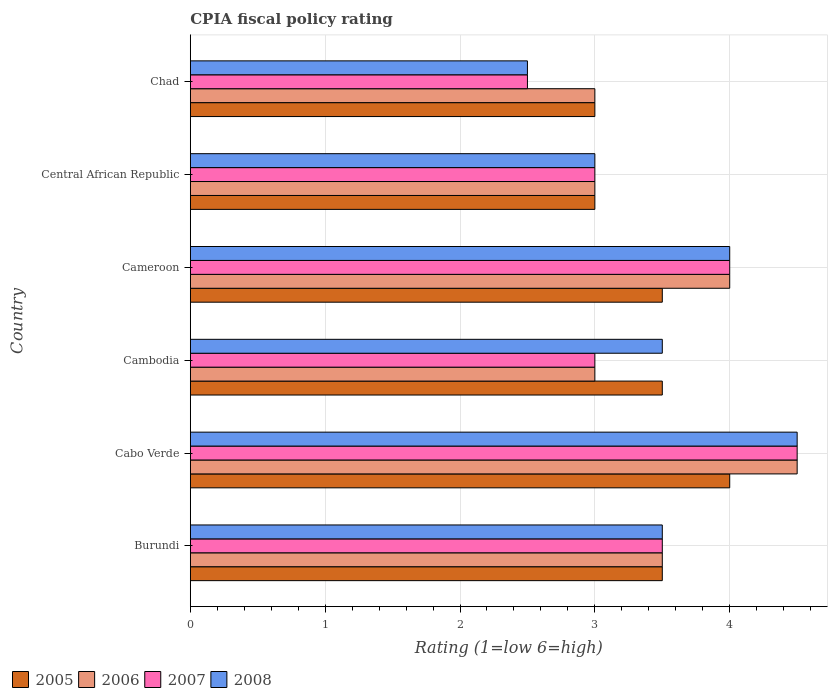How many groups of bars are there?
Provide a succinct answer. 6. Are the number of bars per tick equal to the number of legend labels?
Your answer should be compact. Yes. Are the number of bars on each tick of the Y-axis equal?
Your answer should be very brief. Yes. What is the label of the 1st group of bars from the top?
Offer a very short reply. Chad. Across all countries, what is the maximum CPIA rating in 2007?
Provide a succinct answer. 4.5. Across all countries, what is the minimum CPIA rating in 2005?
Offer a terse response. 3. In which country was the CPIA rating in 2005 maximum?
Give a very brief answer. Cabo Verde. In which country was the CPIA rating in 2005 minimum?
Your answer should be very brief. Central African Republic. What is the difference between the CPIA rating in 2008 in Central African Republic and that in Chad?
Keep it short and to the point. 0.5. What is the average CPIA rating in 2007 per country?
Ensure brevity in your answer.  3.42. What is the difference between the CPIA rating in 2007 and CPIA rating in 2006 in Cambodia?
Offer a terse response. 0. Is the difference between the CPIA rating in 2007 in Cabo Verde and Cameroon greater than the difference between the CPIA rating in 2006 in Cabo Verde and Cameroon?
Provide a short and direct response. No. What is the difference between the highest and the lowest CPIA rating in 2005?
Your answer should be very brief. 1. In how many countries, is the CPIA rating in 2005 greater than the average CPIA rating in 2005 taken over all countries?
Ensure brevity in your answer.  4. What does the 3rd bar from the top in Cabo Verde represents?
Your answer should be compact. 2006. What is the difference between two consecutive major ticks on the X-axis?
Keep it short and to the point. 1. Are the values on the major ticks of X-axis written in scientific E-notation?
Offer a very short reply. No. Does the graph contain grids?
Offer a terse response. Yes. How are the legend labels stacked?
Make the answer very short. Horizontal. What is the title of the graph?
Offer a very short reply. CPIA fiscal policy rating. What is the label or title of the Y-axis?
Give a very brief answer. Country. What is the Rating (1=low 6=high) in 2005 in Burundi?
Your response must be concise. 3.5. What is the Rating (1=low 6=high) of 2006 in Burundi?
Ensure brevity in your answer.  3.5. What is the Rating (1=low 6=high) in 2005 in Cabo Verde?
Give a very brief answer. 4. What is the Rating (1=low 6=high) in 2007 in Cabo Verde?
Make the answer very short. 4.5. What is the Rating (1=low 6=high) in 2006 in Cambodia?
Provide a succinct answer. 3. What is the Rating (1=low 6=high) in 2005 in Cameroon?
Provide a succinct answer. 3.5. What is the Rating (1=low 6=high) of 2007 in Cameroon?
Make the answer very short. 4. What is the Rating (1=low 6=high) of 2008 in Cameroon?
Provide a short and direct response. 4. What is the Rating (1=low 6=high) in 2007 in Central African Republic?
Provide a succinct answer. 3. What is the Rating (1=low 6=high) in 2008 in Central African Republic?
Ensure brevity in your answer.  3. What is the Rating (1=low 6=high) of 2007 in Chad?
Your answer should be very brief. 2.5. Across all countries, what is the maximum Rating (1=low 6=high) of 2006?
Your answer should be compact. 4.5. Across all countries, what is the maximum Rating (1=low 6=high) of 2007?
Your answer should be very brief. 4.5. What is the total Rating (1=low 6=high) of 2006 in the graph?
Provide a succinct answer. 21. What is the total Rating (1=low 6=high) in 2007 in the graph?
Provide a succinct answer. 20.5. What is the difference between the Rating (1=low 6=high) of 2005 in Burundi and that in Cabo Verde?
Give a very brief answer. -0.5. What is the difference between the Rating (1=low 6=high) in 2008 in Burundi and that in Cabo Verde?
Your answer should be very brief. -1. What is the difference between the Rating (1=low 6=high) in 2008 in Burundi and that in Cambodia?
Offer a terse response. 0. What is the difference between the Rating (1=low 6=high) of 2006 in Burundi and that in Cameroon?
Offer a very short reply. -0.5. What is the difference between the Rating (1=low 6=high) of 2007 in Burundi and that in Cameroon?
Give a very brief answer. -0.5. What is the difference between the Rating (1=low 6=high) of 2008 in Burundi and that in Cameroon?
Offer a very short reply. -0.5. What is the difference between the Rating (1=low 6=high) of 2005 in Burundi and that in Central African Republic?
Offer a very short reply. 0.5. What is the difference between the Rating (1=low 6=high) in 2006 in Burundi and that in Central African Republic?
Ensure brevity in your answer.  0.5. What is the difference between the Rating (1=low 6=high) in 2007 in Burundi and that in Central African Republic?
Your response must be concise. 0.5. What is the difference between the Rating (1=low 6=high) of 2008 in Burundi and that in Central African Republic?
Your answer should be very brief. 0.5. What is the difference between the Rating (1=low 6=high) in 2005 in Burundi and that in Chad?
Ensure brevity in your answer.  0.5. What is the difference between the Rating (1=low 6=high) in 2006 in Burundi and that in Chad?
Provide a short and direct response. 0.5. What is the difference between the Rating (1=low 6=high) of 2008 in Cabo Verde and that in Cambodia?
Provide a succinct answer. 1. What is the difference between the Rating (1=low 6=high) in 2005 in Cabo Verde and that in Cameroon?
Your answer should be compact. 0.5. What is the difference between the Rating (1=low 6=high) in 2008 in Cabo Verde and that in Cameroon?
Provide a succinct answer. 0.5. What is the difference between the Rating (1=low 6=high) of 2007 in Cabo Verde and that in Chad?
Give a very brief answer. 2. What is the difference between the Rating (1=low 6=high) of 2008 in Cabo Verde and that in Chad?
Your answer should be compact. 2. What is the difference between the Rating (1=low 6=high) in 2006 in Cambodia and that in Central African Republic?
Give a very brief answer. 0. What is the difference between the Rating (1=low 6=high) in 2005 in Cambodia and that in Chad?
Give a very brief answer. 0.5. What is the difference between the Rating (1=low 6=high) in 2006 in Cambodia and that in Chad?
Provide a succinct answer. 0. What is the difference between the Rating (1=low 6=high) in 2007 in Cambodia and that in Chad?
Give a very brief answer. 0.5. What is the difference between the Rating (1=low 6=high) of 2008 in Cambodia and that in Chad?
Offer a very short reply. 1. What is the difference between the Rating (1=low 6=high) of 2005 in Cameroon and that in Central African Republic?
Your answer should be compact. 0.5. What is the difference between the Rating (1=low 6=high) in 2007 in Cameroon and that in Central African Republic?
Offer a terse response. 1. What is the difference between the Rating (1=low 6=high) in 2008 in Cameroon and that in Central African Republic?
Make the answer very short. 1. What is the difference between the Rating (1=low 6=high) of 2005 in Cameroon and that in Chad?
Ensure brevity in your answer.  0.5. What is the difference between the Rating (1=low 6=high) of 2005 in Central African Republic and that in Chad?
Keep it short and to the point. 0. What is the difference between the Rating (1=low 6=high) of 2006 in Central African Republic and that in Chad?
Offer a very short reply. 0. What is the difference between the Rating (1=low 6=high) in 2007 in Central African Republic and that in Chad?
Your answer should be very brief. 0.5. What is the difference between the Rating (1=low 6=high) of 2008 in Central African Republic and that in Chad?
Ensure brevity in your answer.  0.5. What is the difference between the Rating (1=low 6=high) of 2005 in Burundi and the Rating (1=low 6=high) of 2008 in Cabo Verde?
Offer a terse response. -1. What is the difference between the Rating (1=low 6=high) of 2006 in Burundi and the Rating (1=low 6=high) of 2007 in Cabo Verde?
Your response must be concise. -1. What is the difference between the Rating (1=low 6=high) of 2007 in Burundi and the Rating (1=low 6=high) of 2008 in Cabo Verde?
Offer a very short reply. -1. What is the difference between the Rating (1=low 6=high) in 2005 in Burundi and the Rating (1=low 6=high) in 2006 in Cambodia?
Provide a short and direct response. 0.5. What is the difference between the Rating (1=low 6=high) of 2006 in Burundi and the Rating (1=low 6=high) of 2007 in Cambodia?
Offer a very short reply. 0.5. What is the difference between the Rating (1=low 6=high) of 2006 in Burundi and the Rating (1=low 6=high) of 2008 in Cambodia?
Make the answer very short. 0. What is the difference between the Rating (1=low 6=high) of 2005 in Burundi and the Rating (1=low 6=high) of 2007 in Cameroon?
Your answer should be compact. -0.5. What is the difference between the Rating (1=low 6=high) of 2005 in Burundi and the Rating (1=low 6=high) of 2008 in Cameroon?
Make the answer very short. -0.5. What is the difference between the Rating (1=low 6=high) of 2006 in Burundi and the Rating (1=low 6=high) of 2007 in Cameroon?
Your response must be concise. -0.5. What is the difference between the Rating (1=low 6=high) of 2006 in Burundi and the Rating (1=low 6=high) of 2008 in Cameroon?
Your response must be concise. -0.5. What is the difference between the Rating (1=low 6=high) in 2006 in Burundi and the Rating (1=low 6=high) in 2008 in Central African Republic?
Give a very brief answer. 0.5. What is the difference between the Rating (1=low 6=high) in 2005 in Burundi and the Rating (1=low 6=high) in 2006 in Chad?
Ensure brevity in your answer.  0.5. What is the difference between the Rating (1=low 6=high) of 2005 in Burundi and the Rating (1=low 6=high) of 2008 in Chad?
Give a very brief answer. 1. What is the difference between the Rating (1=low 6=high) in 2006 in Burundi and the Rating (1=low 6=high) in 2007 in Chad?
Make the answer very short. 1. What is the difference between the Rating (1=low 6=high) of 2006 in Burundi and the Rating (1=low 6=high) of 2008 in Chad?
Your answer should be very brief. 1. What is the difference between the Rating (1=low 6=high) of 2007 in Burundi and the Rating (1=low 6=high) of 2008 in Chad?
Your response must be concise. 1. What is the difference between the Rating (1=low 6=high) in 2006 in Cabo Verde and the Rating (1=low 6=high) in 2007 in Cambodia?
Keep it short and to the point. 1.5. What is the difference between the Rating (1=low 6=high) of 2005 in Cabo Verde and the Rating (1=low 6=high) of 2006 in Cameroon?
Your answer should be very brief. 0. What is the difference between the Rating (1=low 6=high) in 2005 in Cabo Verde and the Rating (1=low 6=high) in 2007 in Cameroon?
Give a very brief answer. 0. What is the difference between the Rating (1=low 6=high) of 2006 in Cabo Verde and the Rating (1=low 6=high) of 2007 in Cameroon?
Your response must be concise. 0.5. What is the difference between the Rating (1=low 6=high) in 2007 in Cabo Verde and the Rating (1=low 6=high) in 2008 in Cameroon?
Your answer should be very brief. 0.5. What is the difference between the Rating (1=low 6=high) in 2006 in Cabo Verde and the Rating (1=low 6=high) in 2007 in Central African Republic?
Offer a terse response. 1.5. What is the difference between the Rating (1=low 6=high) of 2006 in Cabo Verde and the Rating (1=low 6=high) of 2008 in Central African Republic?
Provide a succinct answer. 1.5. What is the difference between the Rating (1=low 6=high) in 2007 in Cabo Verde and the Rating (1=low 6=high) in 2008 in Central African Republic?
Offer a terse response. 1.5. What is the difference between the Rating (1=low 6=high) in 2005 in Cabo Verde and the Rating (1=low 6=high) in 2006 in Chad?
Ensure brevity in your answer.  1. What is the difference between the Rating (1=low 6=high) of 2005 in Cabo Verde and the Rating (1=low 6=high) of 2007 in Chad?
Your response must be concise. 1.5. What is the difference between the Rating (1=low 6=high) in 2006 in Cabo Verde and the Rating (1=low 6=high) in 2007 in Chad?
Provide a short and direct response. 2. What is the difference between the Rating (1=low 6=high) of 2005 in Cambodia and the Rating (1=low 6=high) of 2006 in Cameroon?
Provide a short and direct response. -0.5. What is the difference between the Rating (1=low 6=high) in 2006 in Cambodia and the Rating (1=low 6=high) in 2007 in Cameroon?
Offer a terse response. -1. What is the difference between the Rating (1=low 6=high) of 2007 in Cambodia and the Rating (1=low 6=high) of 2008 in Cameroon?
Your response must be concise. -1. What is the difference between the Rating (1=low 6=high) of 2006 in Cambodia and the Rating (1=low 6=high) of 2008 in Central African Republic?
Provide a short and direct response. 0. What is the difference between the Rating (1=low 6=high) in 2007 in Cambodia and the Rating (1=low 6=high) in 2008 in Central African Republic?
Your answer should be compact. 0. What is the difference between the Rating (1=low 6=high) in 2005 in Cambodia and the Rating (1=low 6=high) in 2008 in Chad?
Give a very brief answer. 1. What is the difference between the Rating (1=low 6=high) in 2006 in Cambodia and the Rating (1=low 6=high) in 2007 in Chad?
Your answer should be compact. 0.5. What is the difference between the Rating (1=low 6=high) of 2007 in Cambodia and the Rating (1=low 6=high) of 2008 in Chad?
Make the answer very short. 0.5. What is the difference between the Rating (1=low 6=high) in 2005 in Cameroon and the Rating (1=low 6=high) in 2006 in Chad?
Your answer should be very brief. 0.5. What is the difference between the Rating (1=low 6=high) in 2005 in Cameroon and the Rating (1=low 6=high) in 2007 in Chad?
Your answer should be compact. 1. What is the difference between the Rating (1=low 6=high) of 2005 in Cameroon and the Rating (1=low 6=high) of 2008 in Chad?
Provide a succinct answer. 1. What is the difference between the Rating (1=low 6=high) of 2006 in Cameroon and the Rating (1=low 6=high) of 2007 in Chad?
Ensure brevity in your answer.  1.5. What is the difference between the Rating (1=low 6=high) of 2006 in Cameroon and the Rating (1=low 6=high) of 2008 in Chad?
Give a very brief answer. 1.5. What is the difference between the Rating (1=low 6=high) in 2007 in Cameroon and the Rating (1=low 6=high) in 2008 in Chad?
Offer a terse response. 1.5. What is the difference between the Rating (1=low 6=high) of 2005 in Central African Republic and the Rating (1=low 6=high) of 2006 in Chad?
Your answer should be very brief. 0. What is the difference between the Rating (1=low 6=high) in 2005 in Central African Republic and the Rating (1=low 6=high) in 2008 in Chad?
Offer a very short reply. 0.5. What is the difference between the Rating (1=low 6=high) in 2006 in Central African Republic and the Rating (1=low 6=high) in 2007 in Chad?
Your answer should be very brief. 0.5. What is the difference between the Rating (1=low 6=high) of 2006 in Central African Republic and the Rating (1=low 6=high) of 2008 in Chad?
Your response must be concise. 0.5. What is the difference between the Rating (1=low 6=high) of 2007 in Central African Republic and the Rating (1=low 6=high) of 2008 in Chad?
Your answer should be compact. 0.5. What is the average Rating (1=low 6=high) in 2005 per country?
Give a very brief answer. 3.42. What is the average Rating (1=low 6=high) of 2007 per country?
Your answer should be very brief. 3.42. What is the difference between the Rating (1=low 6=high) of 2005 and Rating (1=low 6=high) of 2008 in Burundi?
Provide a succinct answer. 0. What is the difference between the Rating (1=low 6=high) of 2006 and Rating (1=low 6=high) of 2007 in Burundi?
Provide a short and direct response. 0. What is the difference between the Rating (1=low 6=high) in 2006 and Rating (1=low 6=high) in 2008 in Burundi?
Your response must be concise. 0. What is the difference between the Rating (1=low 6=high) of 2007 and Rating (1=low 6=high) of 2008 in Burundi?
Your answer should be very brief. 0. What is the difference between the Rating (1=low 6=high) of 2005 and Rating (1=low 6=high) of 2006 in Cabo Verde?
Offer a very short reply. -0.5. What is the difference between the Rating (1=low 6=high) of 2006 and Rating (1=low 6=high) of 2007 in Cabo Verde?
Make the answer very short. 0. What is the difference between the Rating (1=low 6=high) in 2006 and Rating (1=low 6=high) in 2008 in Cabo Verde?
Make the answer very short. 0. What is the difference between the Rating (1=low 6=high) in 2007 and Rating (1=low 6=high) in 2008 in Cabo Verde?
Offer a terse response. 0. What is the difference between the Rating (1=low 6=high) of 2005 and Rating (1=low 6=high) of 2006 in Cameroon?
Provide a short and direct response. -0.5. What is the difference between the Rating (1=low 6=high) in 2005 and Rating (1=low 6=high) in 2007 in Cameroon?
Offer a very short reply. -0.5. What is the difference between the Rating (1=low 6=high) in 2006 and Rating (1=low 6=high) in 2007 in Cameroon?
Ensure brevity in your answer.  0. What is the difference between the Rating (1=low 6=high) in 2006 and Rating (1=low 6=high) in 2008 in Cameroon?
Make the answer very short. 0. What is the difference between the Rating (1=low 6=high) of 2005 and Rating (1=low 6=high) of 2006 in Central African Republic?
Make the answer very short. 0. What is the difference between the Rating (1=low 6=high) of 2005 and Rating (1=low 6=high) of 2007 in Central African Republic?
Your answer should be compact. 0. What is the difference between the Rating (1=low 6=high) in 2006 and Rating (1=low 6=high) in 2008 in Central African Republic?
Give a very brief answer. 0. What is the difference between the Rating (1=low 6=high) in 2005 and Rating (1=low 6=high) in 2007 in Chad?
Provide a succinct answer. 0.5. What is the difference between the Rating (1=low 6=high) in 2005 and Rating (1=low 6=high) in 2008 in Chad?
Give a very brief answer. 0.5. What is the difference between the Rating (1=low 6=high) of 2006 and Rating (1=low 6=high) of 2008 in Chad?
Provide a short and direct response. 0.5. What is the difference between the Rating (1=low 6=high) in 2007 and Rating (1=low 6=high) in 2008 in Chad?
Offer a terse response. 0. What is the ratio of the Rating (1=low 6=high) in 2008 in Burundi to that in Cabo Verde?
Make the answer very short. 0.78. What is the ratio of the Rating (1=low 6=high) of 2007 in Burundi to that in Cambodia?
Offer a very short reply. 1.17. What is the ratio of the Rating (1=low 6=high) of 2008 in Burundi to that in Cambodia?
Offer a terse response. 1. What is the ratio of the Rating (1=low 6=high) of 2008 in Burundi to that in Cameroon?
Your answer should be compact. 0.88. What is the ratio of the Rating (1=low 6=high) of 2008 in Burundi to that in Central African Republic?
Your answer should be very brief. 1.17. What is the ratio of the Rating (1=low 6=high) in 2006 in Burundi to that in Chad?
Your answer should be very brief. 1.17. What is the ratio of the Rating (1=low 6=high) of 2005 in Cabo Verde to that in Cambodia?
Your answer should be compact. 1.14. What is the ratio of the Rating (1=low 6=high) of 2008 in Cabo Verde to that in Cambodia?
Keep it short and to the point. 1.29. What is the ratio of the Rating (1=low 6=high) of 2005 in Cabo Verde to that in Cameroon?
Offer a terse response. 1.14. What is the ratio of the Rating (1=low 6=high) in 2006 in Cabo Verde to that in Cameroon?
Provide a short and direct response. 1.12. What is the ratio of the Rating (1=low 6=high) of 2005 in Cabo Verde to that in Chad?
Ensure brevity in your answer.  1.33. What is the ratio of the Rating (1=low 6=high) in 2006 in Cabo Verde to that in Chad?
Provide a succinct answer. 1.5. What is the ratio of the Rating (1=low 6=high) in 2007 in Cabo Verde to that in Chad?
Provide a short and direct response. 1.8. What is the ratio of the Rating (1=low 6=high) in 2008 in Cabo Verde to that in Chad?
Offer a terse response. 1.8. What is the ratio of the Rating (1=low 6=high) in 2006 in Cambodia to that in Cameroon?
Your answer should be compact. 0.75. What is the ratio of the Rating (1=low 6=high) in 2006 in Cambodia to that in Central African Republic?
Offer a very short reply. 1. What is the ratio of the Rating (1=low 6=high) in 2008 in Cambodia to that in Central African Republic?
Your answer should be very brief. 1.17. What is the ratio of the Rating (1=low 6=high) of 2005 in Cambodia to that in Chad?
Offer a terse response. 1.17. What is the ratio of the Rating (1=low 6=high) in 2007 in Cambodia to that in Chad?
Make the answer very short. 1.2. What is the ratio of the Rating (1=low 6=high) in 2008 in Cambodia to that in Chad?
Provide a succinct answer. 1.4. What is the ratio of the Rating (1=low 6=high) of 2007 in Cameroon to that in Central African Republic?
Keep it short and to the point. 1.33. What is the ratio of the Rating (1=low 6=high) of 2008 in Cameroon to that in Chad?
Your answer should be compact. 1.6. What is the ratio of the Rating (1=low 6=high) in 2005 in Central African Republic to that in Chad?
Ensure brevity in your answer.  1. What is the ratio of the Rating (1=low 6=high) in 2006 in Central African Republic to that in Chad?
Your answer should be very brief. 1. What is the ratio of the Rating (1=low 6=high) in 2008 in Central African Republic to that in Chad?
Your response must be concise. 1.2. What is the difference between the highest and the second highest Rating (1=low 6=high) of 2005?
Ensure brevity in your answer.  0.5. What is the difference between the highest and the lowest Rating (1=low 6=high) in 2007?
Provide a succinct answer. 2. 